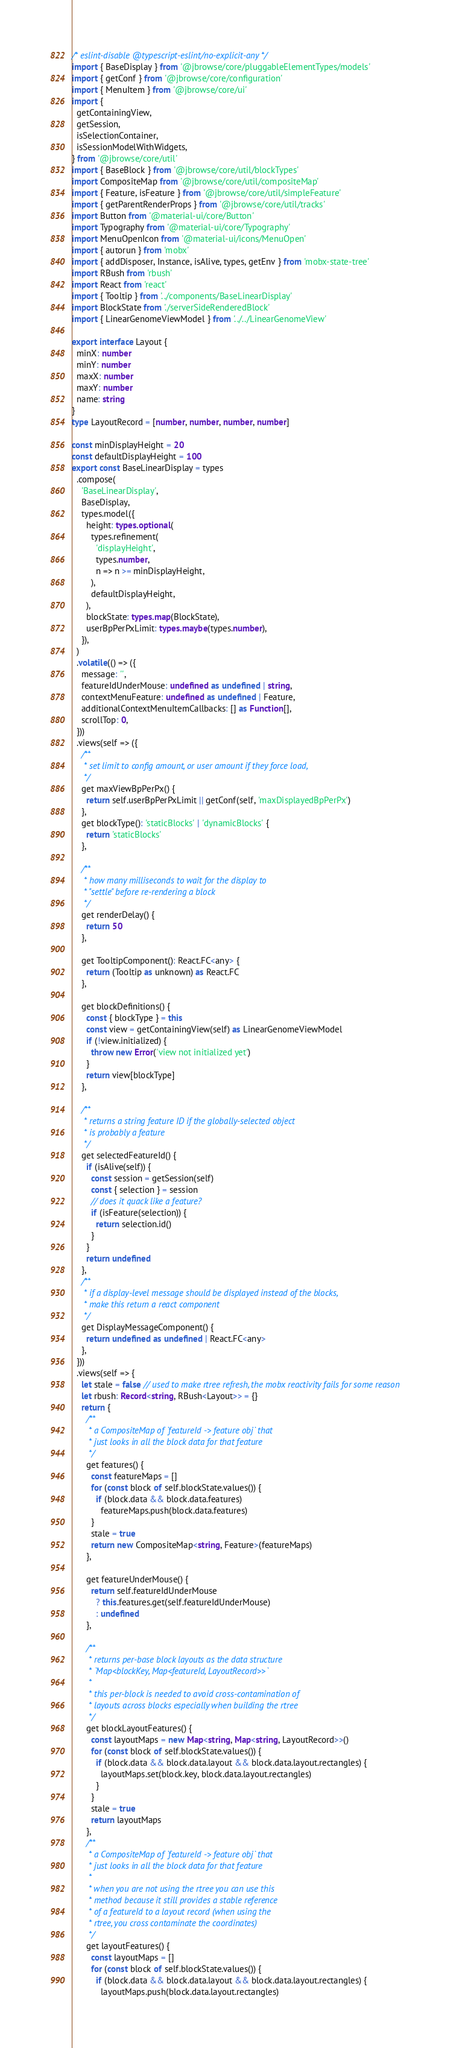Convert code to text. <code><loc_0><loc_0><loc_500><loc_500><_TypeScript_>/* eslint-disable @typescript-eslint/no-explicit-any */
import { BaseDisplay } from '@jbrowse/core/pluggableElementTypes/models'
import { getConf } from '@jbrowse/core/configuration'
import { MenuItem } from '@jbrowse/core/ui'
import {
  getContainingView,
  getSession,
  isSelectionContainer,
  isSessionModelWithWidgets,
} from '@jbrowse/core/util'
import { BaseBlock } from '@jbrowse/core/util/blockTypes'
import CompositeMap from '@jbrowse/core/util/compositeMap'
import { Feature, isFeature } from '@jbrowse/core/util/simpleFeature'
import { getParentRenderProps } from '@jbrowse/core/util/tracks'
import Button from '@material-ui/core/Button'
import Typography from '@material-ui/core/Typography'
import MenuOpenIcon from '@material-ui/icons/MenuOpen'
import { autorun } from 'mobx'
import { addDisposer, Instance, isAlive, types, getEnv } from 'mobx-state-tree'
import RBush from 'rbush'
import React from 'react'
import { Tooltip } from '../components/BaseLinearDisplay'
import BlockState from './serverSideRenderedBlock'
import { LinearGenomeViewModel } from '../../LinearGenomeView'

export interface Layout {
  minX: number
  minY: number
  maxX: number
  maxY: number
  name: string
}
type LayoutRecord = [number, number, number, number]

const minDisplayHeight = 20
const defaultDisplayHeight = 100
export const BaseLinearDisplay = types
  .compose(
    'BaseLinearDisplay',
    BaseDisplay,
    types.model({
      height: types.optional(
        types.refinement(
          'displayHeight',
          types.number,
          n => n >= minDisplayHeight,
        ),
        defaultDisplayHeight,
      ),
      blockState: types.map(BlockState),
      userBpPerPxLimit: types.maybe(types.number),
    }),
  )
  .volatile(() => ({
    message: '',
    featureIdUnderMouse: undefined as undefined | string,
    contextMenuFeature: undefined as undefined | Feature,
    additionalContextMenuItemCallbacks: [] as Function[],
    scrollTop: 0,
  }))
  .views(self => ({
    /**
     * set limit to config amount, or user amount if they force load,
     */
    get maxViewBpPerPx() {
      return self.userBpPerPxLimit || getConf(self, 'maxDisplayedBpPerPx')
    },
    get blockType(): 'staticBlocks' | 'dynamicBlocks' {
      return 'staticBlocks'
    },

    /**
     * how many milliseconds to wait for the display to
     * "settle" before re-rendering a block
     */
    get renderDelay() {
      return 50
    },

    get TooltipComponent(): React.FC<any> {
      return (Tooltip as unknown) as React.FC
    },

    get blockDefinitions() {
      const { blockType } = this
      const view = getContainingView(self) as LinearGenomeViewModel
      if (!view.initialized) {
        throw new Error('view not initialized yet')
      }
      return view[blockType]
    },

    /**
     * returns a string feature ID if the globally-selected object
     * is probably a feature
     */
    get selectedFeatureId() {
      if (isAlive(self)) {
        const session = getSession(self)
        const { selection } = session
        // does it quack like a feature?
        if (isFeature(selection)) {
          return selection.id()
        }
      }
      return undefined
    },
    /**
     * if a display-level message should be displayed instead of the blocks,
     * make this return a react component
     */
    get DisplayMessageComponent() {
      return undefined as undefined | React.FC<any>
    },
  }))
  .views(self => {
    let stale = false // used to make rtree refresh, the mobx reactivity fails for some reason
    let rbush: Record<string, RBush<Layout>> = {}
    return {
      /**
       * a CompositeMap of `featureId -> feature obj` that
       * just looks in all the block data for that feature
       */
      get features() {
        const featureMaps = []
        for (const block of self.blockState.values()) {
          if (block.data && block.data.features)
            featureMaps.push(block.data.features)
        }
        stale = true
        return new CompositeMap<string, Feature>(featureMaps)
      },

      get featureUnderMouse() {
        return self.featureIdUnderMouse
          ? this.features.get(self.featureIdUnderMouse)
          : undefined
      },

      /**
       * returns per-base block layouts as the data structure
       * `Map<blockKey, Map<featureId, LayoutRecord>>`
       *
       * this per-block is needed to avoid cross-contamination of
       * layouts across blocks especially when building the rtree
       */
      get blockLayoutFeatures() {
        const layoutMaps = new Map<string, Map<string, LayoutRecord>>()
        for (const block of self.blockState.values()) {
          if (block.data && block.data.layout && block.data.layout.rectangles) {
            layoutMaps.set(block.key, block.data.layout.rectangles)
          }
        }
        stale = true
        return layoutMaps
      },
      /**
       * a CompositeMap of `featureId -> feature obj` that
       * just looks in all the block data for that feature
       *
       * when you are not using the rtree you can use this
       * method because it still provides a stable reference
       * of a featureId to a layout record (when using the
       * rtree, you cross contaminate the coordinates)
       */
      get layoutFeatures() {
        const layoutMaps = []
        for (const block of self.blockState.values()) {
          if (block.data && block.data.layout && block.data.layout.rectangles) {
            layoutMaps.push(block.data.layout.rectangles)</code> 